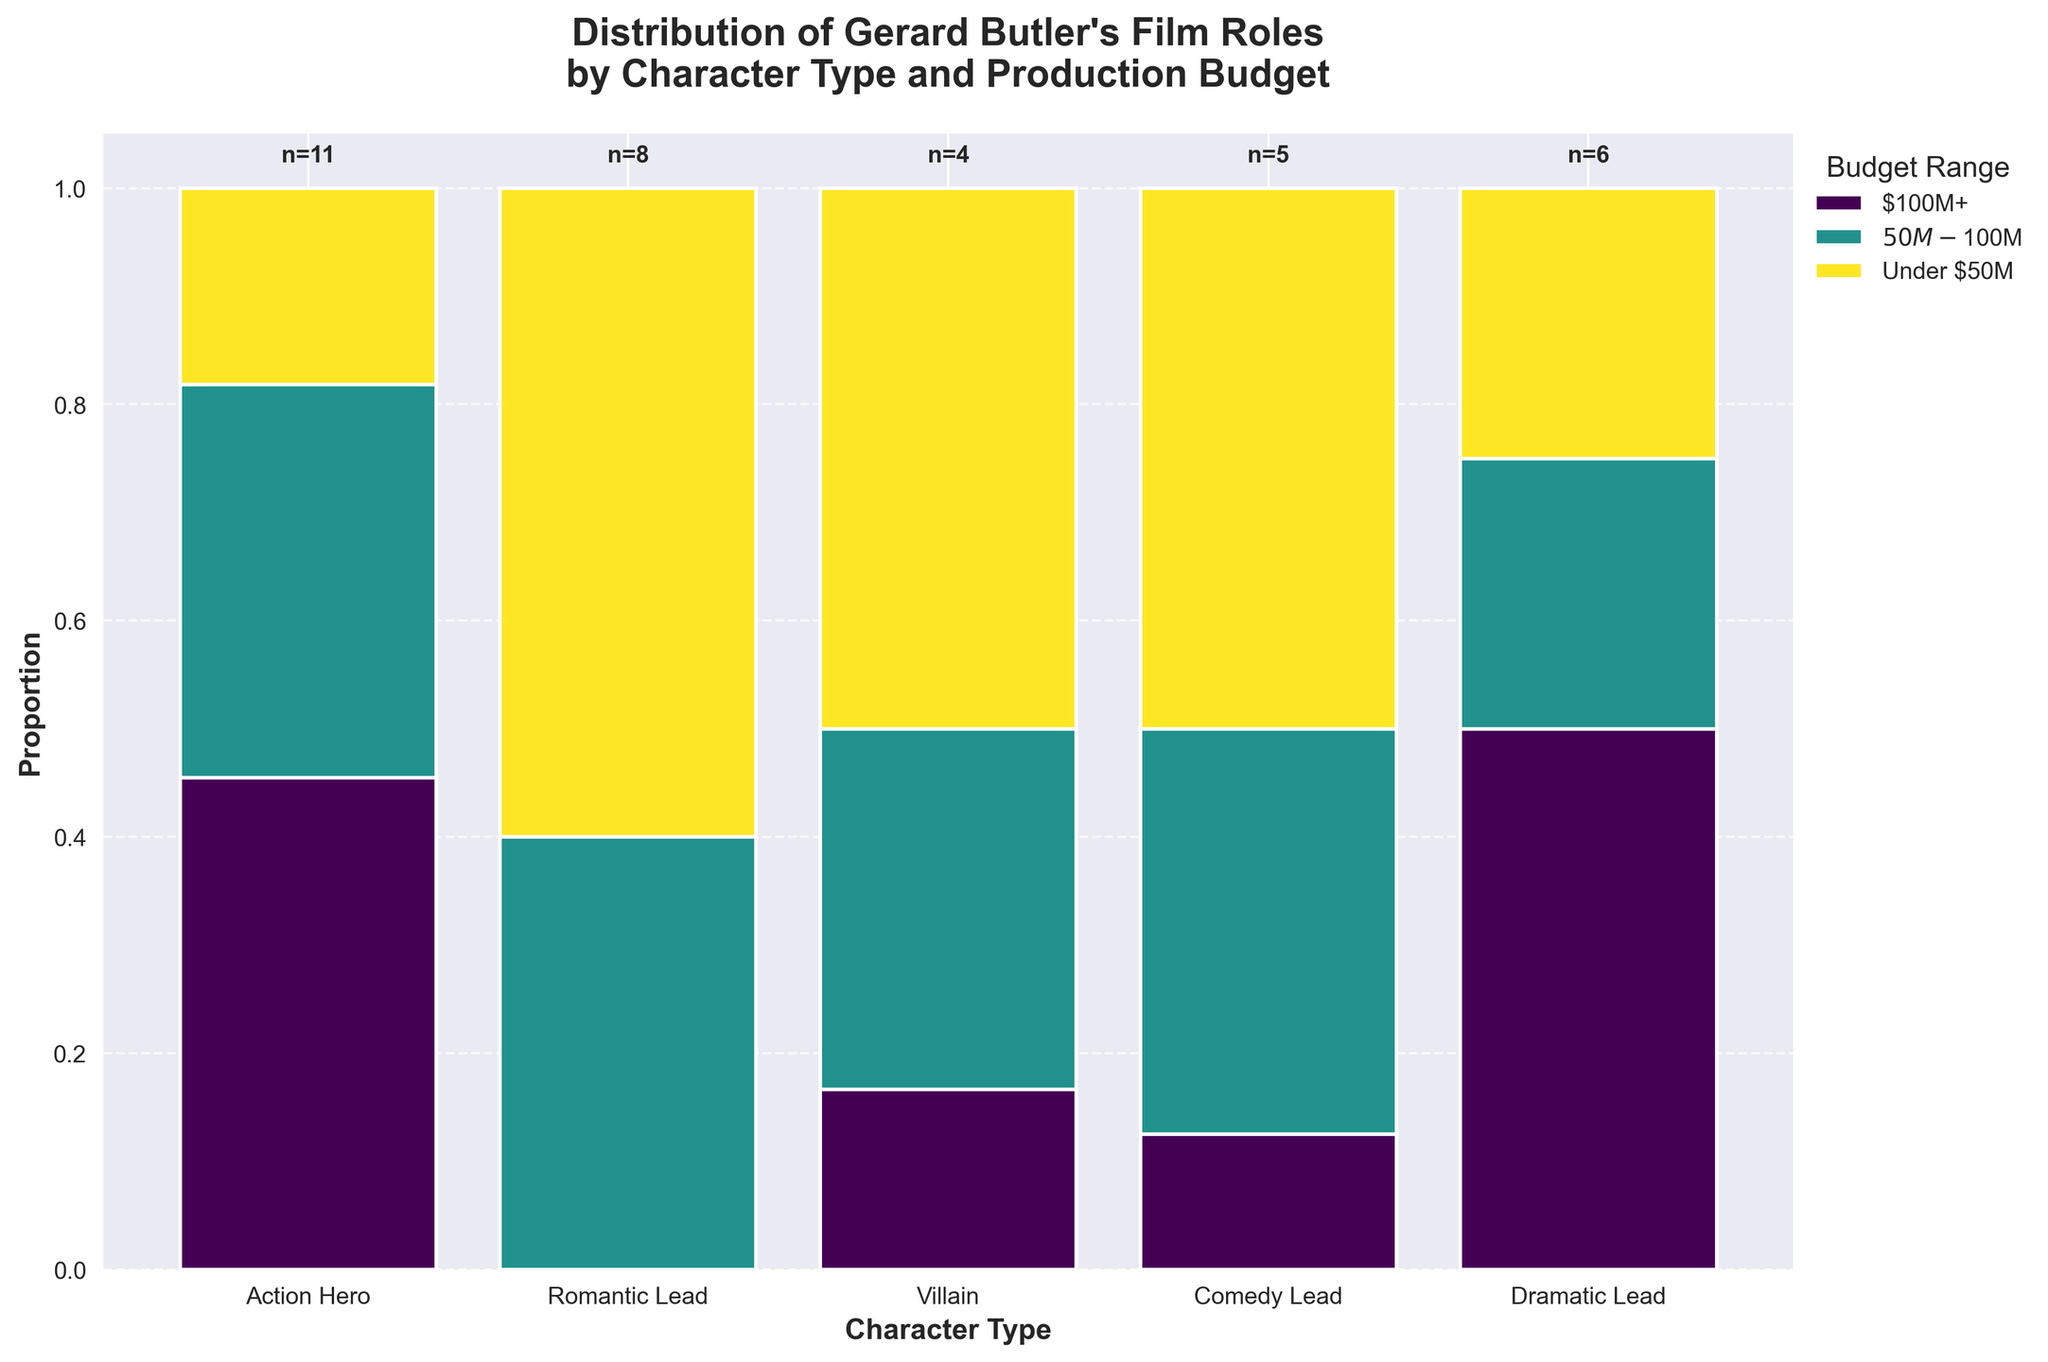what is the title of the plot? The title is generally located at the top of the plot in larger, bold text. It serves as a brief description of what the plot illustrates. Here, it reads: "Distribution of Gerard Butler's Film Roles by Character Type and Production Budget".
Answer: Distribution of Gerard Butler's Film Roles by Character Type and Production Budget What character type has the highest proportion in the $100M+ budget range? To determine this, look for the tallest segment within the $100M+ budget color bar. The Action Hero category has the tallest segment.
Answer: Action Hero Which budget range is missing any representation for Comedy Leads? Find where the Comedy Lead bar is completely absent. The bar is missing in the $100M+ budget range.
Answer: $100M+ What is the total number of films where Gerard Butler played an Action Hero? Look at the text "n=" above the Action Hero bar. It shows the total count, which is 11.
Answer: 11 Compare the proportion of Romantic Leads in the $50M-$100M and Under $50M budget ranges. Which is higher? To compare, observe the relative heights of segments within the Romantic Lead bar. The segment for Under $50M is higher than the one for $50M-$100M.
Answer: Under $50M Are there more films where Gerard Butler played a Dramatic Lead or a Villain budgeted under $50M? Check the count above the respective bars for Dramatic Lead and Villain, and specifically look in the Under $50M segments. The text above indicates that Dramatic Lead has 3 films, while Villain has just 1.
Answer: Dramatic Lead Which character type and budget range combination has the highest count of films? The count can be seen directly within each bar segment. Action Hero in the $100M+ budget range has the highest count, which is 5 films.
Answer: Action Hero, $100M+ Which character type has the most even distribution across all budget ranges? Look for the character type bar where the segments are closest in height. Romantic Lead shows relatively even distribution across all budget ranges.
Answer: Romantic Lead How many more films did Gerard Butler feature in as a Romantic Lead than a Villain? Referring to the counts above the bars, Romantic Lead has a total of 8 and Villain has 4. The difference is 8 - 4 = 4.
Answer: 4 Which budget range is most frequently associated with Gerard Butler’s film roles overall? Summing up proportions for each budget range across all character types, the $50M-$100M range appears most frequently.
Answer: $50M-$100M 